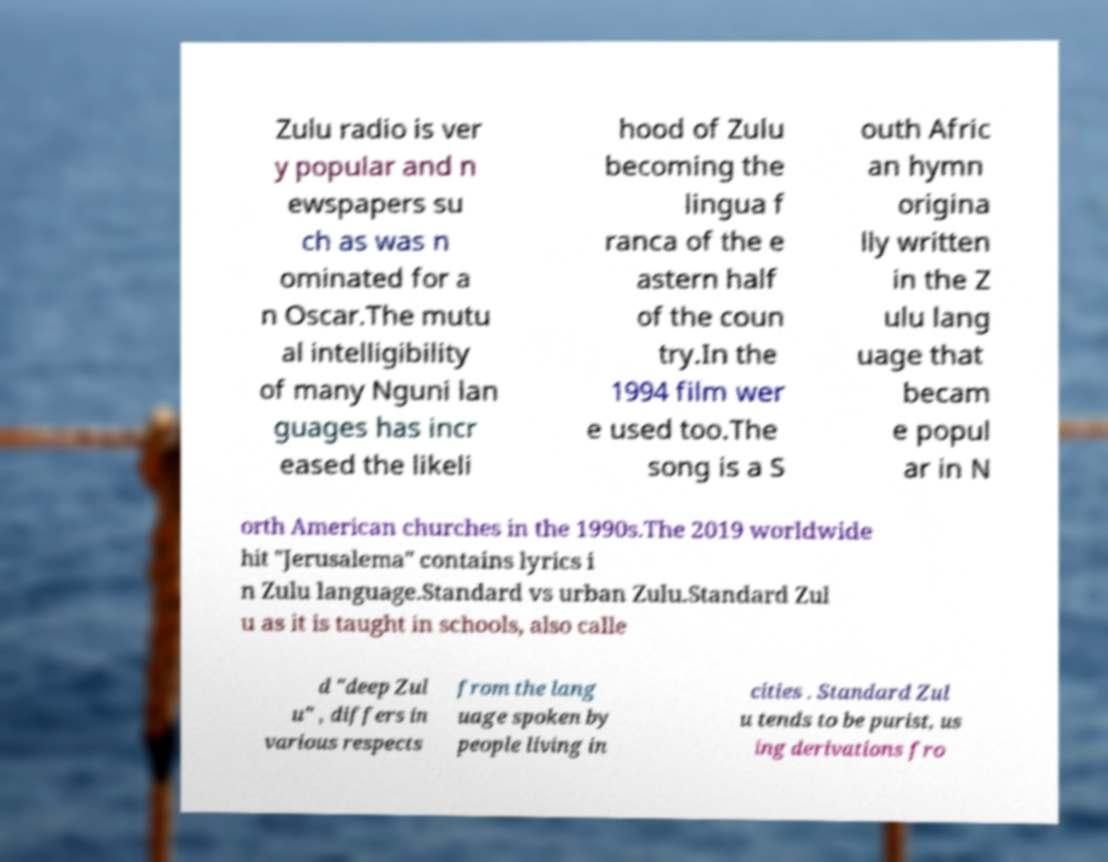For documentation purposes, I need the text within this image transcribed. Could you provide that? Zulu radio is ver y popular and n ewspapers su ch as was n ominated for a n Oscar.The mutu al intelligibility of many Nguni lan guages has incr eased the likeli hood of Zulu becoming the lingua f ranca of the e astern half of the coun try.In the 1994 film wer e used too.The song is a S outh Afric an hymn origina lly written in the Z ulu lang uage that becam e popul ar in N orth American churches in the 1990s.The 2019 worldwide hit "Jerusalema" contains lyrics i n Zulu language.Standard vs urban Zulu.Standard Zul u as it is taught in schools, also calle d "deep Zul u" , differs in various respects from the lang uage spoken by people living in cities . Standard Zul u tends to be purist, us ing derivations fro 